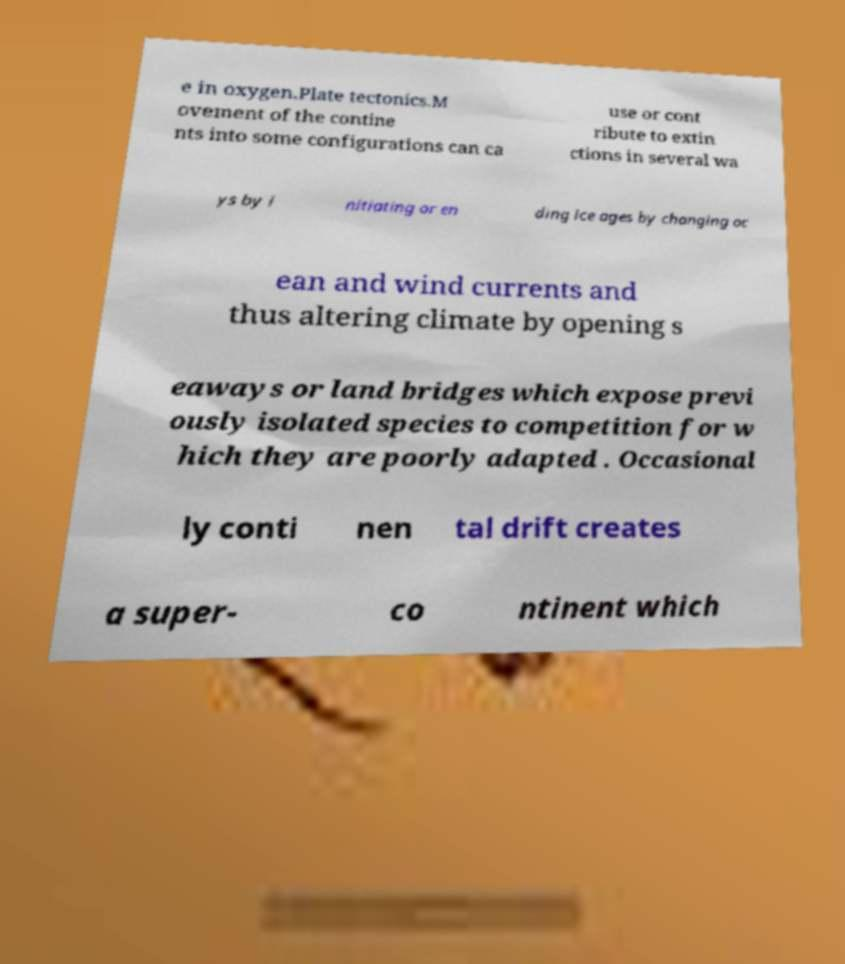Can you read and provide the text displayed in the image?This photo seems to have some interesting text. Can you extract and type it out for me? e in oxygen.Plate tectonics.M ovement of the contine nts into some configurations can ca use or cont ribute to extin ctions in several wa ys by i nitiating or en ding ice ages by changing oc ean and wind currents and thus altering climate by opening s eaways or land bridges which expose previ ously isolated species to competition for w hich they are poorly adapted . Occasional ly conti nen tal drift creates a super- co ntinent which 